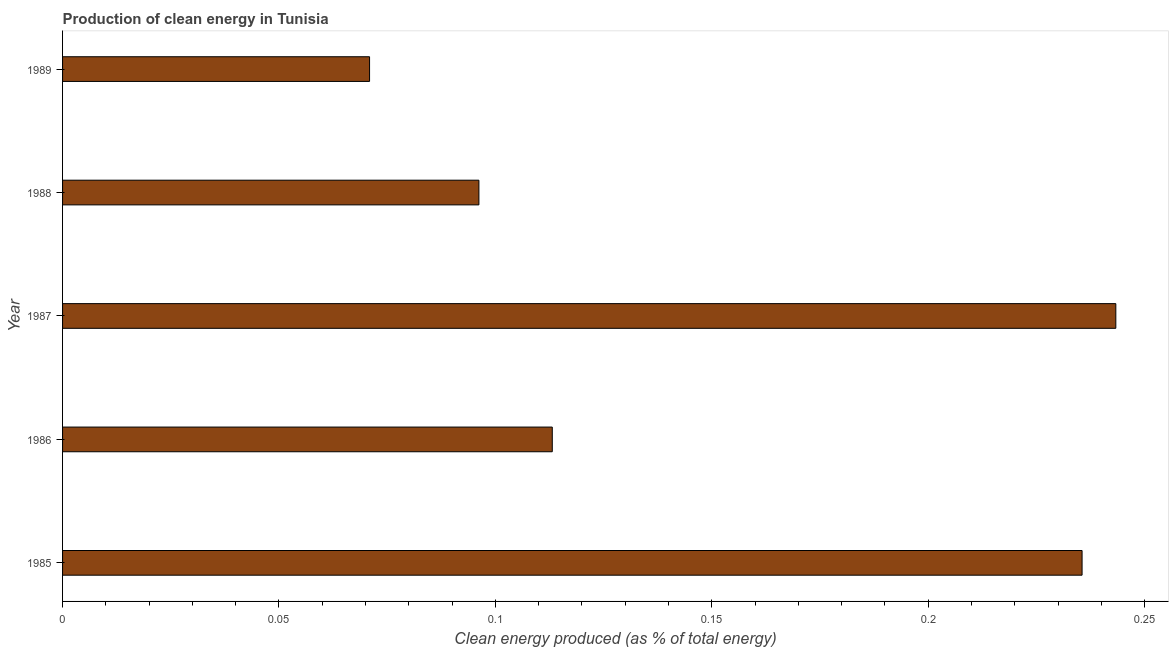Does the graph contain any zero values?
Your response must be concise. No. What is the title of the graph?
Your answer should be compact. Production of clean energy in Tunisia. What is the label or title of the X-axis?
Keep it short and to the point. Clean energy produced (as % of total energy). What is the label or title of the Y-axis?
Make the answer very short. Year. What is the production of clean energy in 1987?
Ensure brevity in your answer.  0.24. Across all years, what is the maximum production of clean energy?
Offer a terse response. 0.24. Across all years, what is the minimum production of clean energy?
Offer a terse response. 0.07. In which year was the production of clean energy maximum?
Your response must be concise. 1987. In which year was the production of clean energy minimum?
Keep it short and to the point. 1989. What is the sum of the production of clean energy?
Provide a short and direct response. 0.76. What is the difference between the production of clean energy in 1986 and 1989?
Your answer should be very brief. 0.04. What is the average production of clean energy per year?
Make the answer very short. 0.15. What is the median production of clean energy?
Your answer should be compact. 0.11. In how many years, is the production of clean energy greater than 0.17 %?
Your response must be concise. 2. Do a majority of the years between 1985 and 1988 (inclusive) have production of clean energy greater than 0.05 %?
Keep it short and to the point. Yes. What is the ratio of the production of clean energy in 1986 to that in 1988?
Give a very brief answer. 1.18. Is the difference between the production of clean energy in 1987 and 1989 greater than the difference between any two years?
Provide a succinct answer. Yes. What is the difference between the highest and the second highest production of clean energy?
Offer a terse response. 0.01. Is the sum of the production of clean energy in 1988 and 1989 greater than the maximum production of clean energy across all years?
Make the answer very short. No. What is the difference between the highest and the lowest production of clean energy?
Ensure brevity in your answer.  0.17. In how many years, is the production of clean energy greater than the average production of clean energy taken over all years?
Ensure brevity in your answer.  2. What is the difference between two consecutive major ticks on the X-axis?
Make the answer very short. 0.05. What is the Clean energy produced (as % of total energy) in 1985?
Your response must be concise. 0.24. What is the Clean energy produced (as % of total energy) in 1986?
Your response must be concise. 0.11. What is the Clean energy produced (as % of total energy) in 1987?
Give a very brief answer. 0.24. What is the Clean energy produced (as % of total energy) of 1988?
Keep it short and to the point. 0.1. What is the Clean energy produced (as % of total energy) in 1989?
Your response must be concise. 0.07. What is the difference between the Clean energy produced (as % of total energy) in 1985 and 1986?
Your answer should be very brief. 0.12. What is the difference between the Clean energy produced (as % of total energy) in 1985 and 1987?
Keep it short and to the point. -0.01. What is the difference between the Clean energy produced (as % of total energy) in 1985 and 1988?
Make the answer very short. 0.14. What is the difference between the Clean energy produced (as % of total energy) in 1985 and 1989?
Offer a very short reply. 0.16. What is the difference between the Clean energy produced (as % of total energy) in 1986 and 1987?
Provide a succinct answer. -0.13. What is the difference between the Clean energy produced (as % of total energy) in 1986 and 1988?
Offer a terse response. 0.02. What is the difference between the Clean energy produced (as % of total energy) in 1986 and 1989?
Keep it short and to the point. 0.04. What is the difference between the Clean energy produced (as % of total energy) in 1987 and 1988?
Your response must be concise. 0.15. What is the difference between the Clean energy produced (as % of total energy) in 1987 and 1989?
Make the answer very short. 0.17. What is the difference between the Clean energy produced (as % of total energy) in 1988 and 1989?
Your answer should be compact. 0.03. What is the ratio of the Clean energy produced (as % of total energy) in 1985 to that in 1986?
Your answer should be compact. 2.08. What is the ratio of the Clean energy produced (as % of total energy) in 1985 to that in 1988?
Give a very brief answer. 2.45. What is the ratio of the Clean energy produced (as % of total energy) in 1985 to that in 1989?
Keep it short and to the point. 3.32. What is the ratio of the Clean energy produced (as % of total energy) in 1986 to that in 1987?
Your response must be concise. 0.47. What is the ratio of the Clean energy produced (as % of total energy) in 1986 to that in 1988?
Offer a very short reply. 1.18. What is the ratio of the Clean energy produced (as % of total energy) in 1986 to that in 1989?
Make the answer very short. 1.59. What is the ratio of the Clean energy produced (as % of total energy) in 1987 to that in 1988?
Make the answer very short. 2.53. What is the ratio of the Clean energy produced (as % of total energy) in 1987 to that in 1989?
Ensure brevity in your answer.  3.43. What is the ratio of the Clean energy produced (as % of total energy) in 1988 to that in 1989?
Your response must be concise. 1.36. 